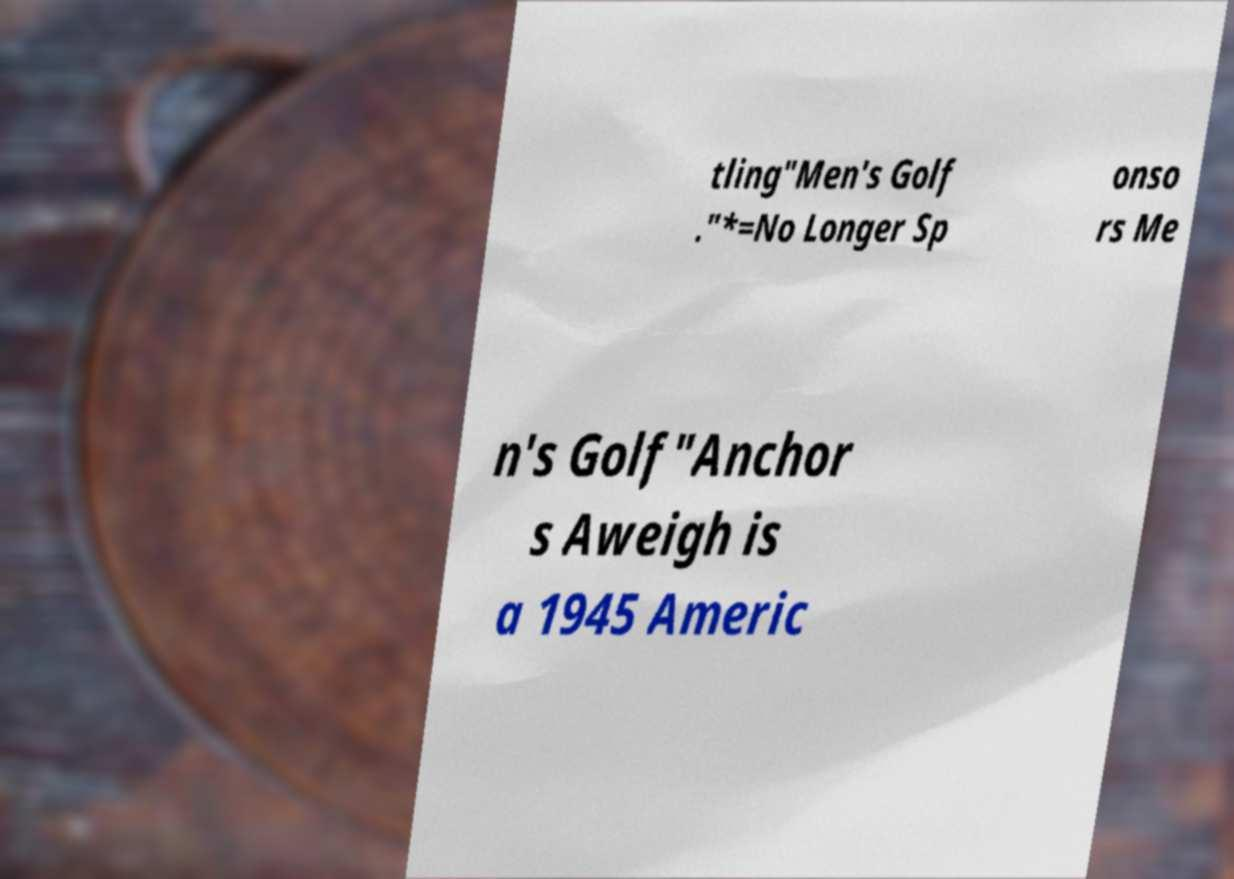Can you accurately transcribe the text from the provided image for me? tling"Men's Golf ."*=No Longer Sp onso rs Me n's Golf"Anchor s Aweigh is a 1945 Americ 